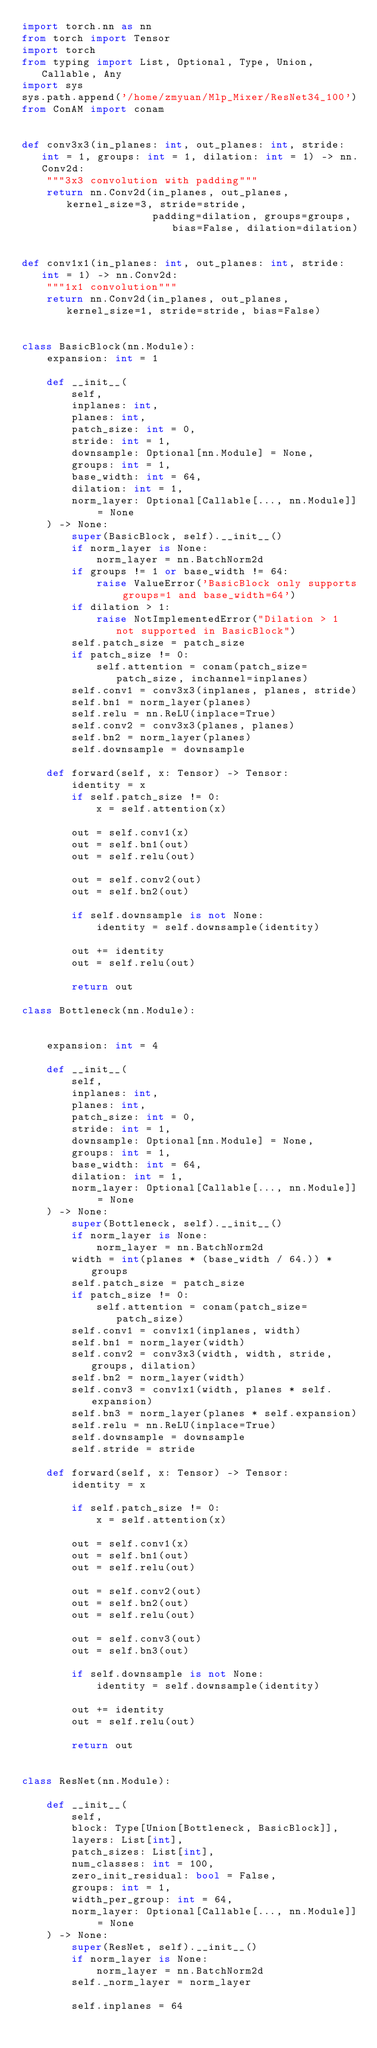<code> <loc_0><loc_0><loc_500><loc_500><_Python_>import torch.nn as nn
from torch import Tensor
import torch
from typing import List, Optional, Type, Union, Callable, Any
import sys
sys.path.append('/home/zmyuan/Mlp_Mixer/ResNet34_100')
from ConAM import conam


def conv3x3(in_planes: int, out_planes: int, stride: int = 1, groups: int = 1, dilation: int = 1) -> nn.Conv2d:
    """3x3 convolution with padding"""
    return nn.Conv2d(in_planes, out_planes, kernel_size=3, stride=stride,
                     padding=dilation, groups=groups, bias=False, dilation=dilation)


def conv1x1(in_planes: int, out_planes: int, stride: int = 1) -> nn.Conv2d:
    """1x1 convolution"""
    return nn.Conv2d(in_planes, out_planes, kernel_size=1, stride=stride, bias=False)


class BasicBlock(nn.Module):
    expansion: int = 1

    def __init__(
        self,
        inplanes: int,
        planes: int,
        patch_size: int = 0,
        stride: int = 1,
        downsample: Optional[nn.Module] = None,
        groups: int = 1,
        base_width: int = 64,
        dilation: int = 1,
        norm_layer: Optional[Callable[..., nn.Module]] = None
    ) -> None:
        super(BasicBlock, self).__init__()
        if norm_layer is None:
            norm_layer = nn.BatchNorm2d
        if groups != 1 or base_width != 64:
            raise ValueError('BasicBlock only supports groups=1 and base_width=64')
        if dilation > 1:
            raise NotImplementedError("Dilation > 1 not supported in BasicBlock")
        self.patch_size = patch_size
        if patch_size != 0:
            self.attention = conam(patch_size=patch_size, inchannel=inplanes)
        self.conv1 = conv3x3(inplanes, planes, stride)
        self.bn1 = norm_layer(planes)
        self.relu = nn.ReLU(inplace=True)
        self.conv2 = conv3x3(planes, planes)
        self.bn2 = norm_layer(planes)
        self.downsample = downsample

    def forward(self, x: Tensor) -> Tensor:
        identity = x
        if self.patch_size != 0:
            x = self.attention(x)

        out = self.conv1(x)
        out = self.bn1(out)
        out = self.relu(out)

        out = self.conv2(out)
        out = self.bn2(out)

        if self.downsample is not None:
            identity = self.downsample(identity)

        out += identity
        out = self.relu(out)

        return out

class Bottleneck(nn.Module):
    

    expansion: int = 4

    def __init__(
        self,
        inplanes: int,
        planes: int,
        patch_size: int = 0,
        stride: int = 1,
        downsample: Optional[nn.Module] = None,
        groups: int = 1,
        base_width: int = 64,
        dilation: int = 1,
        norm_layer: Optional[Callable[..., nn.Module]] = None
    ) -> None:
        super(Bottleneck, self).__init__()
        if norm_layer is None:
            norm_layer = nn.BatchNorm2d
        width = int(planes * (base_width / 64.)) * groups
        self.patch_size = patch_size
        if patch_size != 0:
            self.attention = conam(patch_size=patch_size)
        self.conv1 = conv1x1(inplanes, width)
        self.bn1 = norm_layer(width)
        self.conv2 = conv3x3(width, width, stride, groups, dilation)
        self.bn2 = norm_layer(width)
        self.conv3 = conv1x1(width, planes * self.expansion)
        self.bn3 = norm_layer(planes * self.expansion)
        self.relu = nn.ReLU(inplace=True)
        self.downsample = downsample
        self.stride = stride

    def forward(self, x: Tensor) -> Tensor:
        identity = x

        if self.patch_size != 0:
            x = self.attention(x)

        out = self.conv1(x)
        out = self.bn1(out)
        out = self.relu(out)

        out = self.conv2(out)
        out = self.bn2(out)
        out = self.relu(out)

        out = self.conv3(out)
        out = self.bn3(out)

        if self.downsample is not None:
            identity = self.downsample(identity)

        out += identity
        out = self.relu(out)

        return out


class ResNet(nn.Module):

    def __init__(
        self,
        block: Type[Union[Bottleneck, BasicBlock]],
        layers: List[int],
        patch_sizes: List[int],
        num_classes: int = 100,
        zero_init_residual: bool = False,
        groups: int = 1,
        width_per_group: int = 64,
        norm_layer: Optional[Callable[..., nn.Module]] = None
    ) -> None:
        super(ResNet, self).__init__()
        if norm_layer is None:
            norm_layer = nn.BatchNorm2d
        self._norm_layer = norm_layer

        self.inplanes = 64</code> 